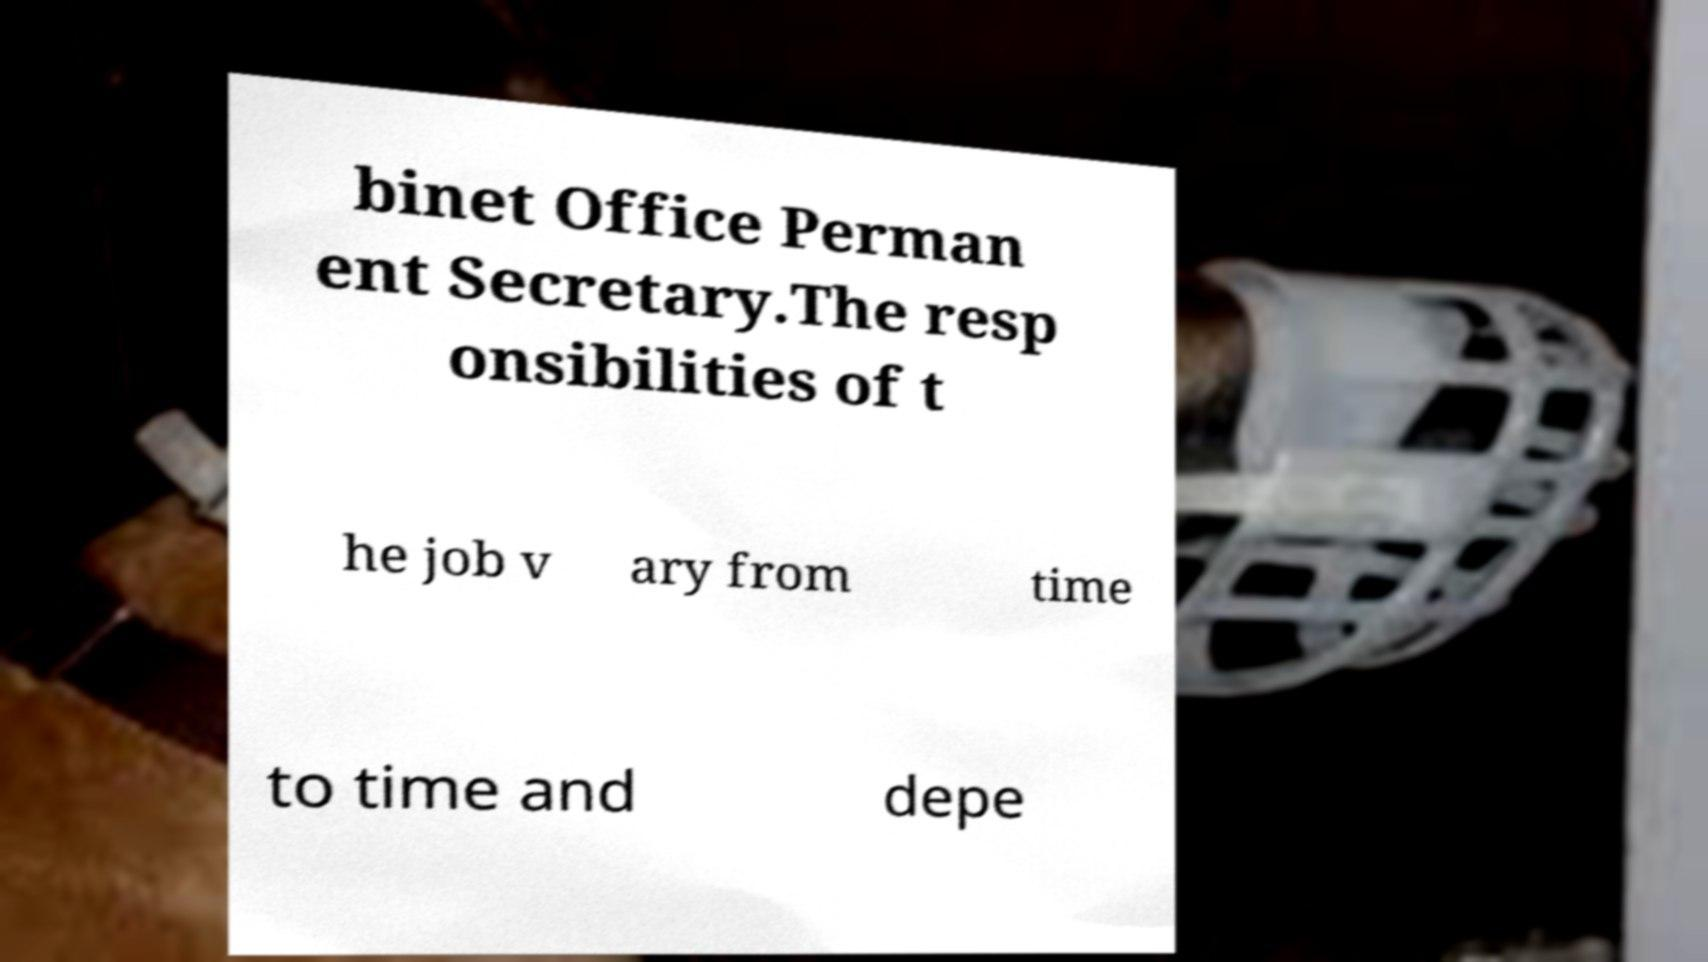Can you read and provide the text displayed in the image?This photo seems to have some interesting text. Can you extract and type it out for me? binet Office Perman ent Secretary.The resp onsibilities of t he job v ary from time to time and depe 